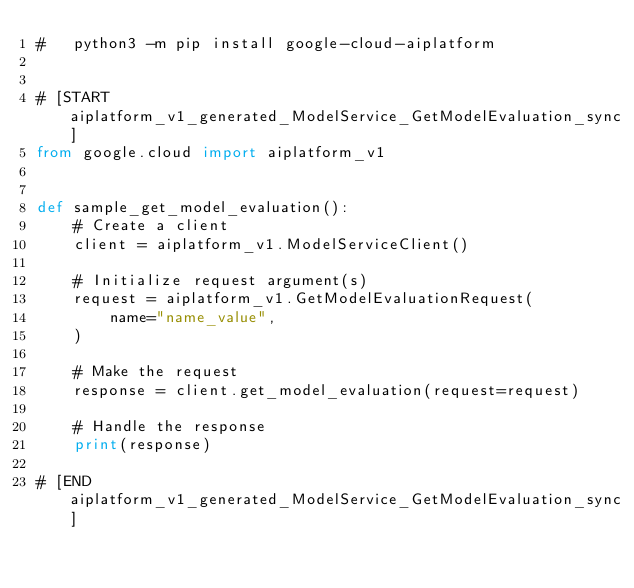Convert code to text. <code><loc_0><loc_0><loc_500><loc_500><_Python_>#   python3 -m pip install google-cloud-aiplatform


# [START aiplatform_v1_generated_ModelService_GetModelEvaluation_sync]
from google.cloud import aiplatform_v1


def sample_get_model_evaluation():
    # Create a client
    client = aiplatform_v1.ModelServiceClient()

    # Initialize request argument(s)
    request = aiplatform_v1.GetModelEvaluationRequest(
        name="name_value",
    )

    # Make the request
    response = client.get_model_evaluation(request=request)

    # Handle the response
    print(response)

# [END aiplatform_v1_generated_ModelService_GetModelEvaluation_sync]
</code> 